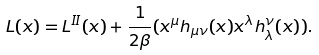Convert formula to latex. <formula><loc_0><loc_0><loc_500><loc_500>L ( x ) = L ^ { I I } ( x ) + \frac { 1 } { 2 \beta } ( x ^ { \mu } h _ { \mu \nu } ( x ) x ^ { \lambda } h _ { \lambda } ^ { \nu } ( x ) ) .</formula> 